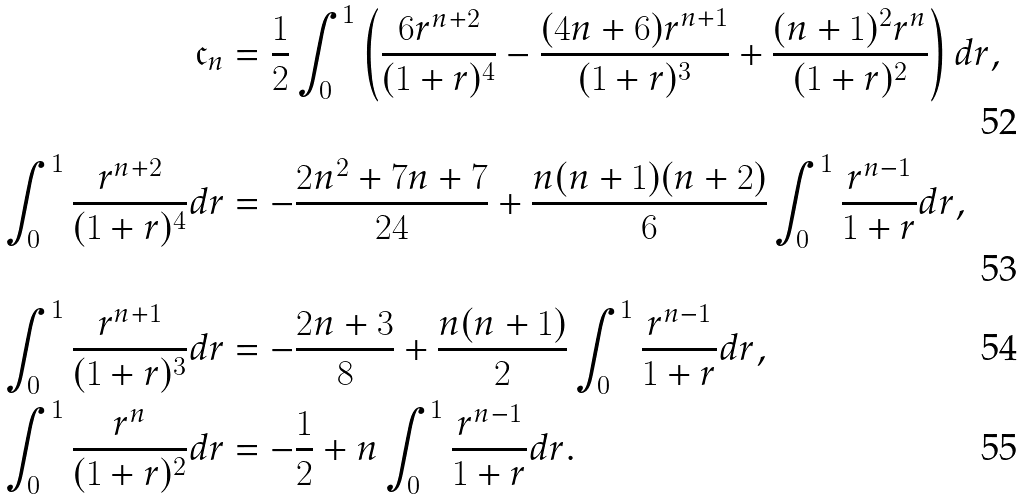Convert formula to latex. <formula><loc_0><loc_0><loc_500><loc_500>\mathfrak { c } _ { n } & = \frac { 1 } { 2 } \int _ { 0 } ^ { 1 } \left ( \frac { 6 r ^ { n + 2 } } { ( 1 + r ) ^ { 4 } } - \frac { ( 4 n + 6 ) r ^ { n + 1 } } { ( 1 + r ) ^ { 3 } } + \frac { ( n + 1 ) ^ { 2 } r ^ { n } } { ( 1 + r ) ^ { 2 } } \right ) d r , \\ \int _ { 0 } ^ { 1 } \frac { r ^ { n + 2 } } { ( 1 + r ) ^ { 4 } } d r & = - \frac { 2 n ^ { 2 } + 7 n + 7 } { 2 4 } + \frac { n ( n + 1 ) ( n + 2 ) } { 6 } \int _ { 0 } ^ { 1 } \frac { r ^ { n - 1 } } { 1 + r } d r , \\ \int _ { 0 } ^ { 1 } \frac { r ^ { n + 1 } } { ( 1 + r ) ^ { 3 } } d r & = - \frac { 2 n + 3 } { 8 } + \frac { n ( n + 1 ) } { 2 } \int _ { 0 } ^ { 1 } \frac { r ^ { n - 1 } } { 1 + r } d r , \\ \int _ { 0 } ^ { 1 } \frac { r ^ { n } } { ( 1 + r ) ^ { 2 } } d r & = - \frac { 1 } { 2 } + n \int _ { 0 } ^ { 1 } \frac { r ^ { n - 1 } } { 1 + r } d r .</formula> 